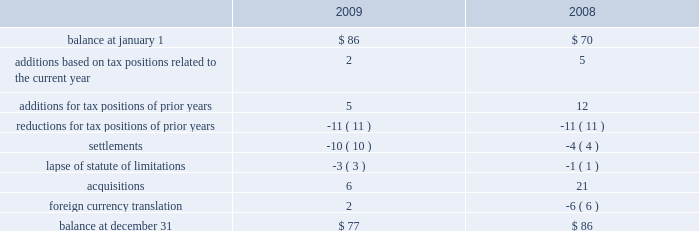At december 31 , 2009 , aon had domestic federal operating loss carryforwards of $ 7 million that will expire at various dates from 2010 to 2024 , state operating loss carryforwards of $ 513 million that will expire at various dates from 2010 to 2028 , and foreign operating and capital loss carryforwards of $ 453 million and $ 252 million , respectively , nearly all of which are subject to indefinite carryforward .
Unrecognized tax benefits the following is a reconciliation of the company 2019s beginning and ending amount of unrecognized tax benefits ( in millions ) : .
As of december 31 , 2009 , $ 61 million of unrecognized tax benefits would impact the effective tax rate if recognized .
Aon does not expect the unrecognized tax positions to change significantly over the next twelve months .
The company recognizes penalties and interest related to unrecognized income tax benefits in its provision for income taxes .
Aon accrued potential penalties of less than $ 1 million during each of 2009 , 2008 and 2007 .
Aon accrued interest of $ 2 million during 2009 and less than $ 1 million during both 2008 and 2007 .
As of december 31 , 2009 and 2008 , aon has recorded a liability for penalties of $ 5 million and $ 4 million , respectively , and for interest of $ 18 million and $ 14 million , respectively .
Aon and its subsidiaries file income tax returns in the u.s .
Federal jurisdiction as well as various state and international jurisdictions .
Aon has substantially concluded all u.s .
Federal income tax matters for years through 2006 .
Material u.s .
State and local income tax jurisdiction examinations have been concluded for years through 2002 .
Aon has concluded income tax examinations in its primary international jurisdictions through 2002. .
Considering the years 2008 and 2009 , what is the variation observed in the foreign currency translation , in millions? 
Rationale: it is the difference between those values .
Computations: (2 - -6)
Answer: 8.0. 